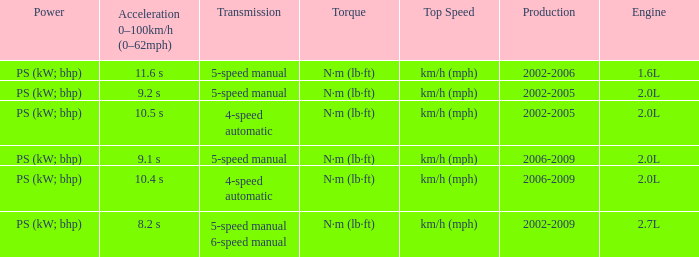What is the top speed of a 4-speed automatic with production in 2002-2005? Km/h (mph). 